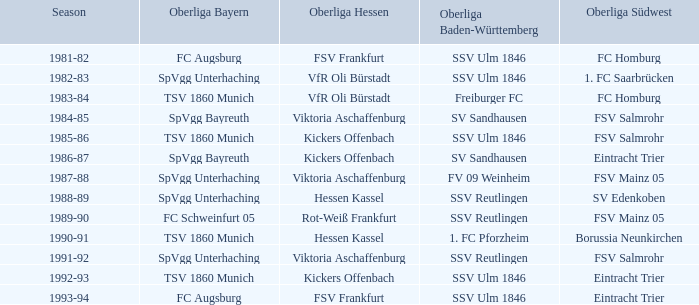Which oberliga bayern includes a season from 1981-82? FC Augsburg. 